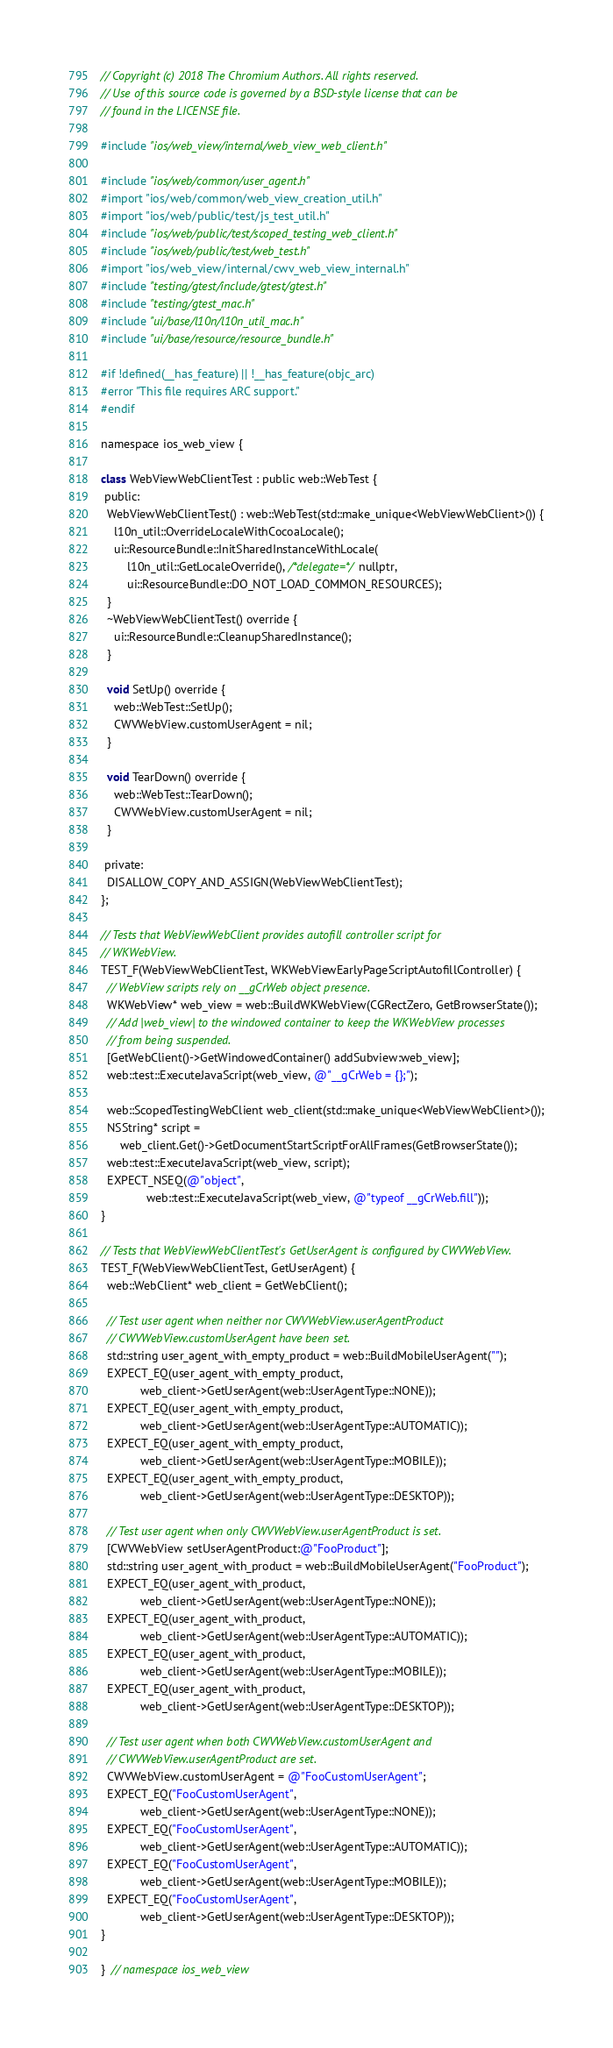Convert code to text. <code><loc_0><loc_0><loc_500><loc_500><_ObjectiveC_>// Copyright (c) 2018 The Chromium Authors. All rights reserved.
// Use of this source code is governed by a BSD-style license that can be
// found in the LICENSE file.

#include "ios/web_view/internal/web_view_web_client.h"

#include "ios/web/common/user_agent.h"
#import "ios/web/common/web_view_creation_util.h"
#import "ios/web/public/test/js_test_util.h"
#include "ios/web/public/test/scoped_testing_web_client.h"
#include "ios/web/public/test/web_test.h"
#import "ios/web_view/internal/cwv_web_view_internal.h"
#include "testing/gtest/include/gtest/gtest.h"
#include "testing/gtest_mac.h"
#include "ui/base/l10n/l10n_util_mac.h"
#include "ui/base/resource/resource_bundle.h"

#if !defined(__has_feature) || !__has_feature(objc_arc)
#error "This file requires ARC support."
#endif

namespace ios_web_view {

class WebViewWebClientTest : public web::WebTest {
 public:
  WebViewWebClientTest() : web::WebTest(std::make_unique<WebViewWebClient>()) {
    l10n_util::OverrideLocaleWithCocoaLocale();
    ui::ResourceBundle::InitSharedInstanceWithLocale(
        l10n_util::GetLocaleOverride(), /*delegate=*/nullptr,
        ui::ResourceBundle::DO_NOT_LOAD_COMMON_RESOURCES);
  }
  ~WebViewWebClientTest() override {
    ui::ResourceBundle::CleanupSharedInstance();
  }

  void SetUp() override {
    web::WebTest::SetUp();
    CWVWebView.customUserAgent = nil;
  }

  void TearDown() override {
    web::WebTest::TearDown();
    CWVWebView.customUserAgent = nil;
  }

 private:
  DISALLOW_COPY_AND_ASSIGN(WebViewWebClientTest);
};

// Tests that WebViewWebClient provides autofill controller script for
// WKWebView.
TEST_F(WebViewWebClientTest, WKWebViewEarlyPageScriptAutofillController) {
  // WebView scripts rely on __gCrWeb object presence.
  WKWebView* web_view = web::BuildWKWebView(CGRectZero, GetBrowserState());
  // Add |web_view| to the windowed container to keep the WKWebView processes
  // from being suspended.
  [GetWebClient()->GetWindowedContainer() addSubview:web_view];
  web::test::ExecuteJavaScript(web_view, @"__gCrWeb = {};");

  web::ScopedTestingWebClient web_client(std::make_unique<WebViewWebClient>());
  NSString* script =
      web_client.Get()->GetDocumentStartScriptForAllFrames(GetBrowserState());
  web::test::ExecuteJavaScript(web_view, script);
  EXPECT_NSEQ(@"object",
              web::test::ExecuteJavaScript(web_view, @"typeof __gCrWeb.fill"));
}

// Tests that WebViewWebClientTest's GetUserAgent is configured by CWVWebView.
TEST_F(WebViewWebClientTest, GetUserAgent) {
  web::WebClient* web_client = GetWebClient();

  // Test user agent when neither nor CWVWebView.userAgentProduct
  // CWVWebView.customUserAgent have been set.
  std::string user_agent_with_empty_product = web::BuildMobileUserAgent("");
  EXPECT_EQ(user_agent_with_empty_product,
            web_client->GetUserAgent(web::UserAgentType::NONE));
  EXPECT_EQ(user_agent_with_empty_product,
            web_client->GetUserAgent(web::UserAgentType::AUTOMATIC));
  EXPECT_EQ(user_agent_with_empty_product,
            web_client->GetUserAgent(web::UserAgentType::MOBILE));
  EXPECT_EQ(user_agent_with_empty_product,
            web_client->GetUserAgent(web::UserAgentType::DESKTOP));

  // Test user agent when only CWVWebView.userAgentProduct is set.
  [CWVWebView setUserAgentProduct:@"FooProduct"];
  std::string user_agent_with_product = web::BuildMobileUserAgent("FooProduct");
  EXPECT_EQ(user_agent_with_product,
            web_client->GetUserAgent(web::UserAgentType::NONE));
  EXPECT_EQ(user_agent_with_product,
            web_client->GetUserAgent(web::UserAgentType::AUTOMATIC));
  EXPECT_EQ(user_agent_with_product,
            web_client->GetUserAgent(web::UserAgentType::MOBILE));
  EXPECT_EQ(user_agent_with_product,
            web_client->GetUserAgent(web::UserAgentType::DESKTOP));

  // Test user agent when both CWVWebView.customUserAgent and
  // CWVWebView.userAgentProduct are set.
  CWVWebView.customUserAgent = @"FooCustomUserAgent";
  EXPECT_EQ("FooCustomUserAgent",
            web_client->GetUserAgent(web::UserAgentType::NONE));
  EXPECT_EQ("FooCustomUserAgent",
            web_client->GetUserAgent(web::UserAgentType::AUTOMATIC));
  EXPECT_EQ("FooCustomUserAgent",
            web_client->GetUserAgent(web::UserAgentType::MOBILE));
  EXPECT_EQ("FooCustomUserAgent",
            web_client->GetUserAgent(web::UserAgentType::DESKTOP));
}

}  // namespace ios_web_view
</code> 